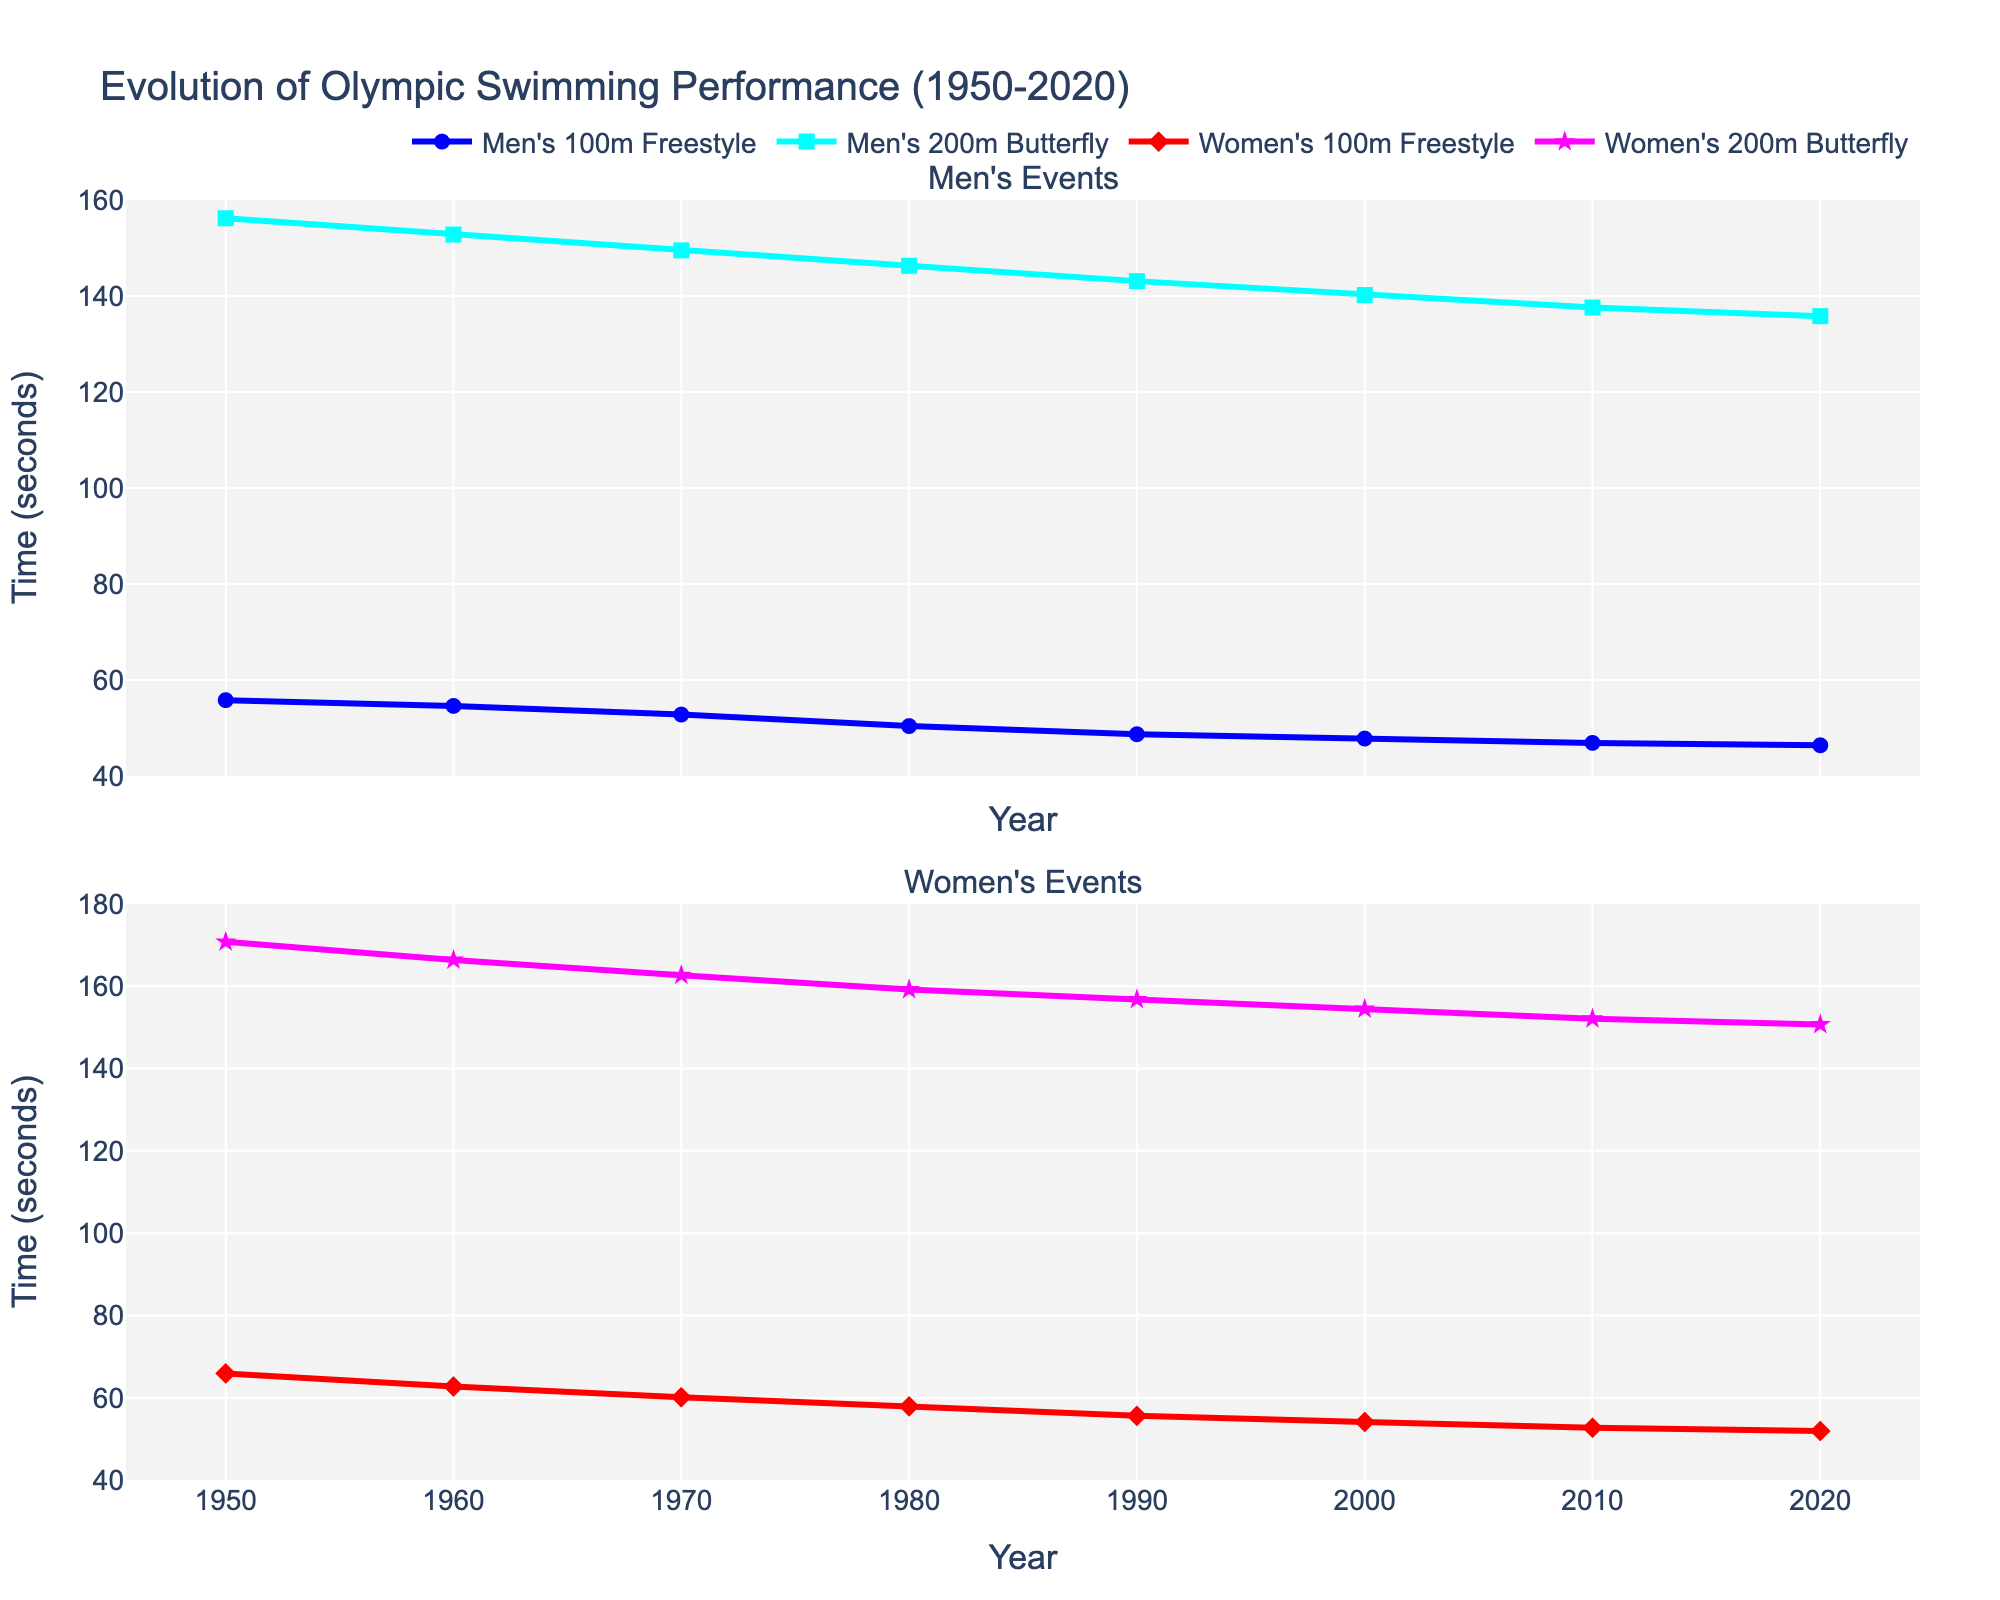What is the general trend observed for the Men's 100m Freestyle times from 1950 to 2020? The times for the Men's 100m Freestyle have generally decreased over the years from 55.8 seconds in 1950 to 46.4 seconds in 2020. This indicates an improvement in performance over the century.
Answer: Decreasing Which event saw the largest improvement in time (in seconds) for women from 1950 to 2020? The Women's 100m Freestyle improved from 65.9 seconds in 1950 to 51.9 seconds in 2020, totaling an improvement of 14 seconds. The Women's 200m Butterfly improved from 170.8 seconds in 1950 to 150.7 seconds in 2020, totaling an improvement of 20.1 seconds. Therefore, the 200m Butterfly saw the largest improvement.
Answer: Women's 200m Butterfly Which gender's 100m Freestyle event had a greater reduction in time from 1950 to 2020? The Men's 100m Freestyle times reduced from 55.8 seconds to 46.4 seconds, a reduction of 9.4 seconds. The Women's 100m Freestyle times reduced from 65.9 seconds to 51.9 seconds, a reduction of 14 seconds. Therefore, women showed a greater reduction.
Answer: Women's In which decade did the Men's 200m Butterfly see the most significant improvement in time? Between each decade, the changes are as follows: 1950-1960 (3.4 secs), 1960-1970 (3.3 secs), 1970-1980 (3.2 secs), 1980-1990 (3.2 secs), 1990-2000 (2.9 secs), 2000-2010 (2.6 secs), 2010-2020 (1.8 secs). The biggest improvement was from 1950 to 1960.
Answer: 1950-1960 By how many seconds did the Women's 100m Freestyle time improve more than the Men's 100m Freestyle time from 1950 to 2020? Men improved by 9.4 seconds (55.8-46.4), and women by 14 seconds (65.9-51.9). The difference is 14 - 9.4 = 4.6 seconds.
Answer: 4.6 seconds What colors represent the Men's and Women's 100m Freestyle events in the plot? In the plot, the Men's 100m Freestyle is represented by blue, and the Women's 100m Freestyle is represented by red.
Answer: Blue and Red Which event has the least variance in time over the years for men and women? By observing the trends, the Men's 100m Freestyle has the least variance as the line appears more consistently decreasing without irregular fluctuations compared to the other events.
Answer: Men's 100m Freestyle 